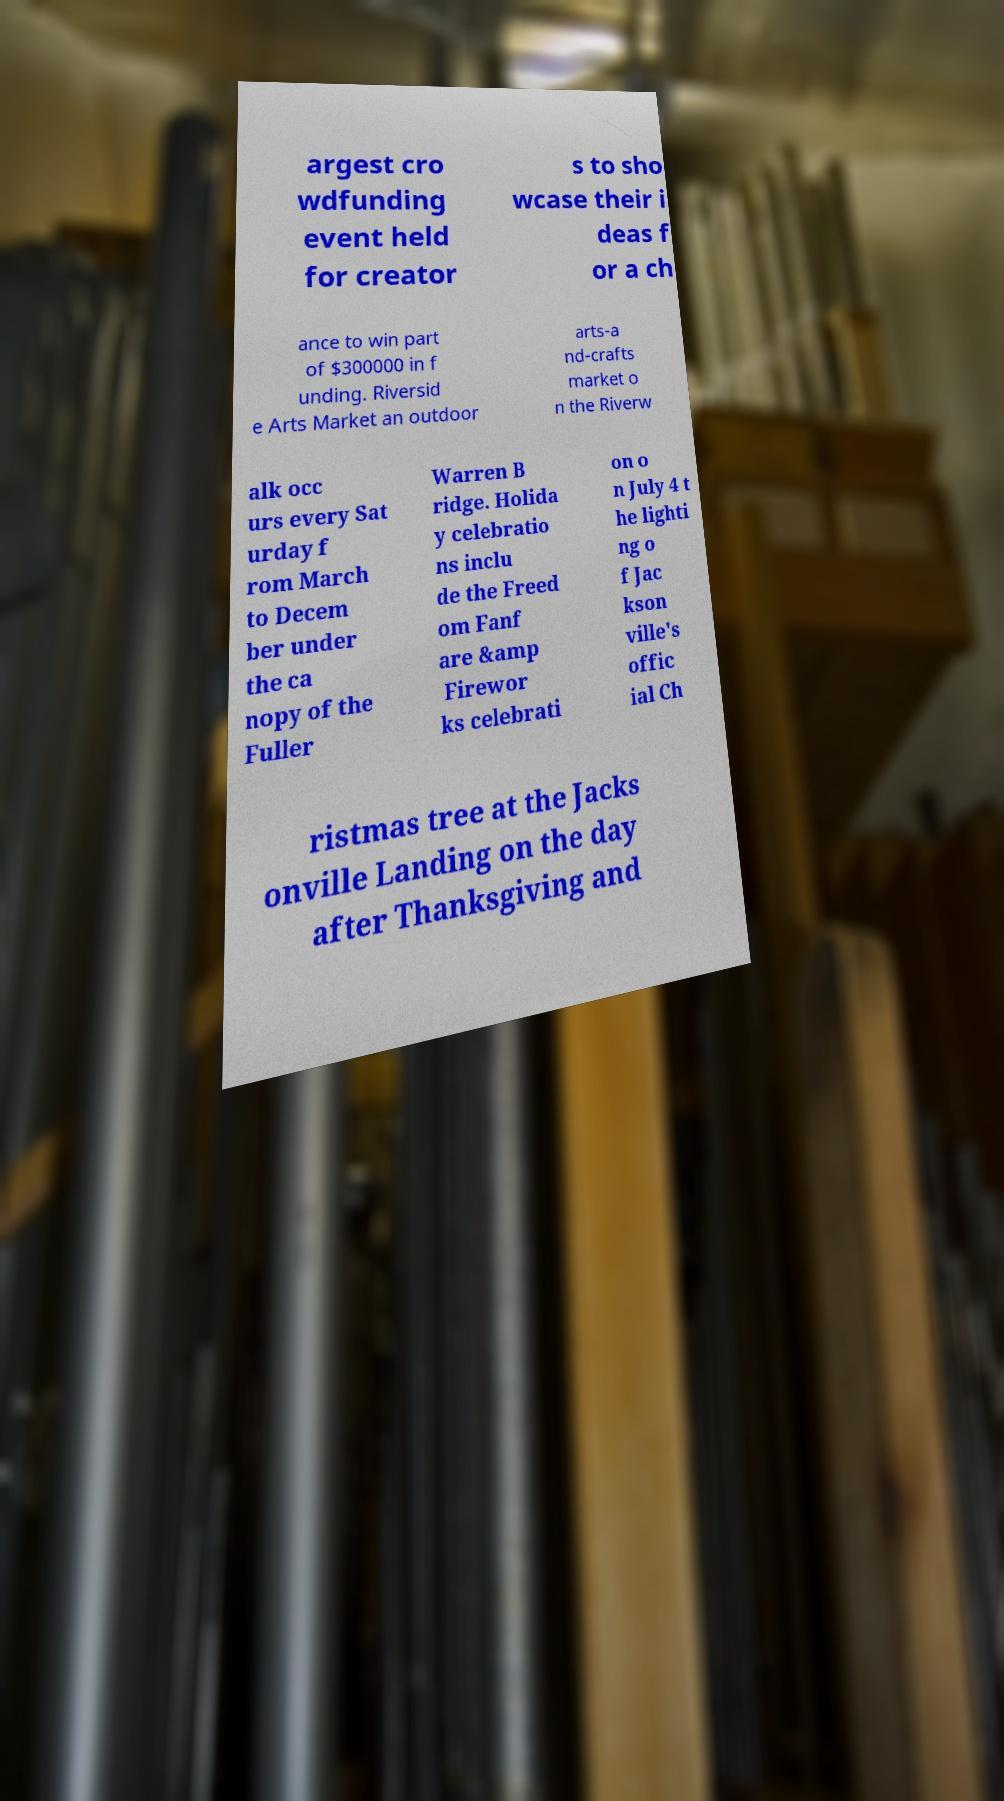What messages or text are displayed in this image? I need them in a readable, typed format. argest cro wdfunding event held for creator s to sho wcase their i deas f or a ch ance to win part of $300000 in f unding. Riversid e Arts Market an outdoor arts-a nd-crafts market o n the Riverw alk occ urs every Sat urday f rom March to Decem ber under the ca nopy of the Fuller Warren B ridge. Holida y celebratio ns inclu de the Freed om Fanf are &amp Firewor ks celebrati on o n July 4 t he lighti ng o f Jac kson ville's offic ial Ch ristmas tree at the Jacks onville Landing on the day after Thanksgiving and 